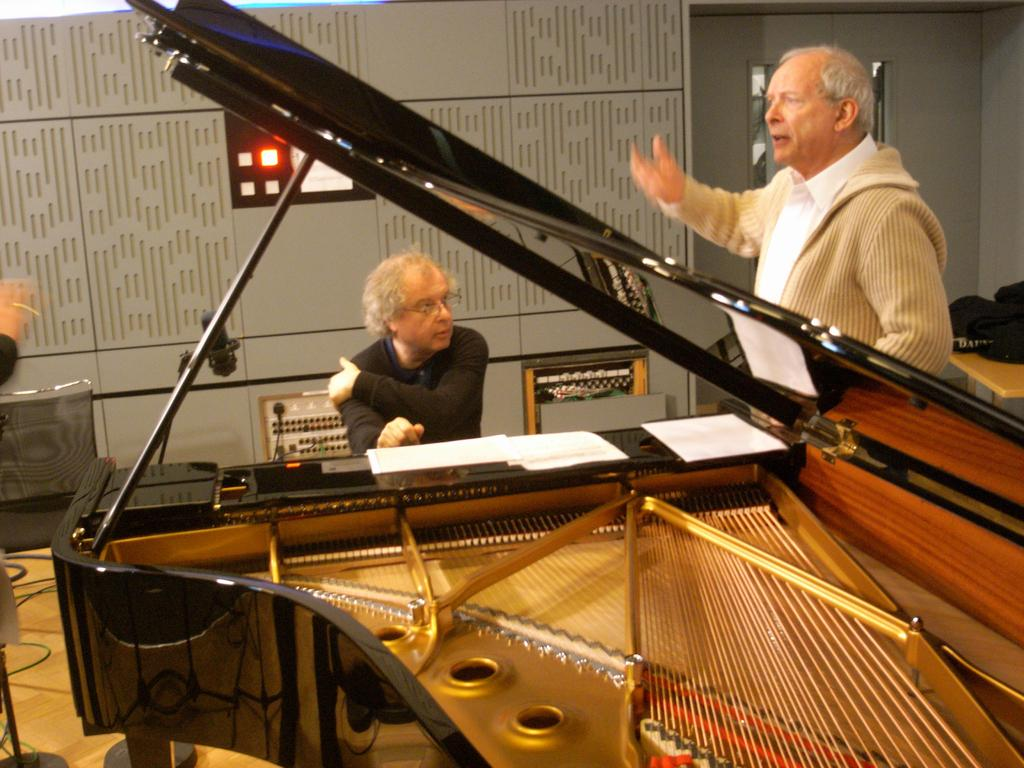What is the man in the image doing? The man is sitting in front of a piano in the image. Can you describe the other person in the image? There is another man standing in the image. How many ladybugs can be seen on the piano in the image? There are no ladybugs present in the image; it only features two men, one sitting in front of a piano and the other standing. 